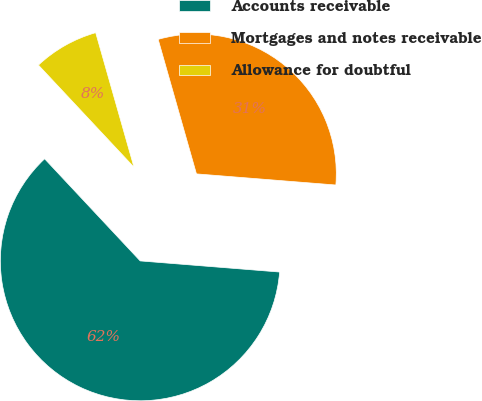Convert chart to OTSL. <chart><loc_0><loc_0><loc_500><loc_500><pie_chart><fcel>Accounts receivable<fcel>Mortgages and notes receivable<fcel>Allowance for doubtful<nl><fcel>61.76%<fcel>30.68%<fcel>7.56%<nl></chart> 